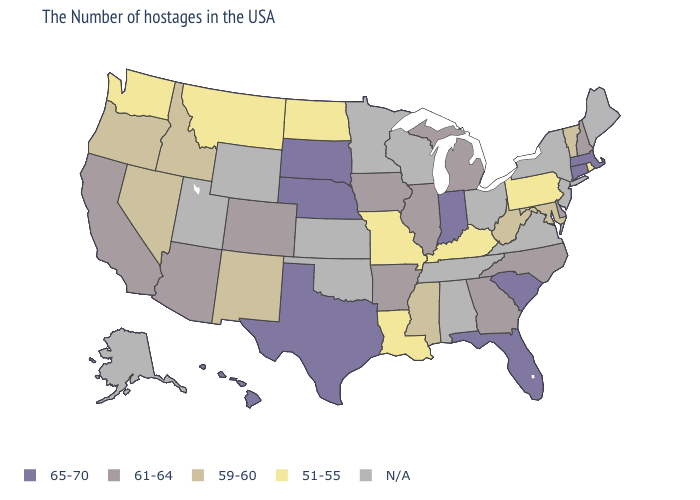What is the value of Illinois?
Answer briefly. 61-64. Does the map have missing data?
Be succinct. Yes. What is the value of Utah?
Keep it brief. N/A. Among the states that border Connecticut , which have the lowest value?
Be succinct. Rhode Island. Among the states that border Texas , which have the highest value?
Short answer required. Arkansas. Is the legend a continuous bar?
Be succinct. No. Name the states that have a value in the range 59-60?
Write a very short answer. Vermont, Maryland, West Virginia, Mississippi, New Mexico, Idaho, Nevada, Oregon. What is the highest value in the South ?
Answer briefly. 65-70. What is the highest value in states that border Kentucky?
Keep it brief. 65-70. Among the states that border Oklahoma , does New Mexico have the lowest value?
Answer briefly. No. Among the states that border Tennessee , which have the lowest value?
Answer briefly. Kentucky, Missouri. What is the value of Wyoming?
Be succinct. N/A. 